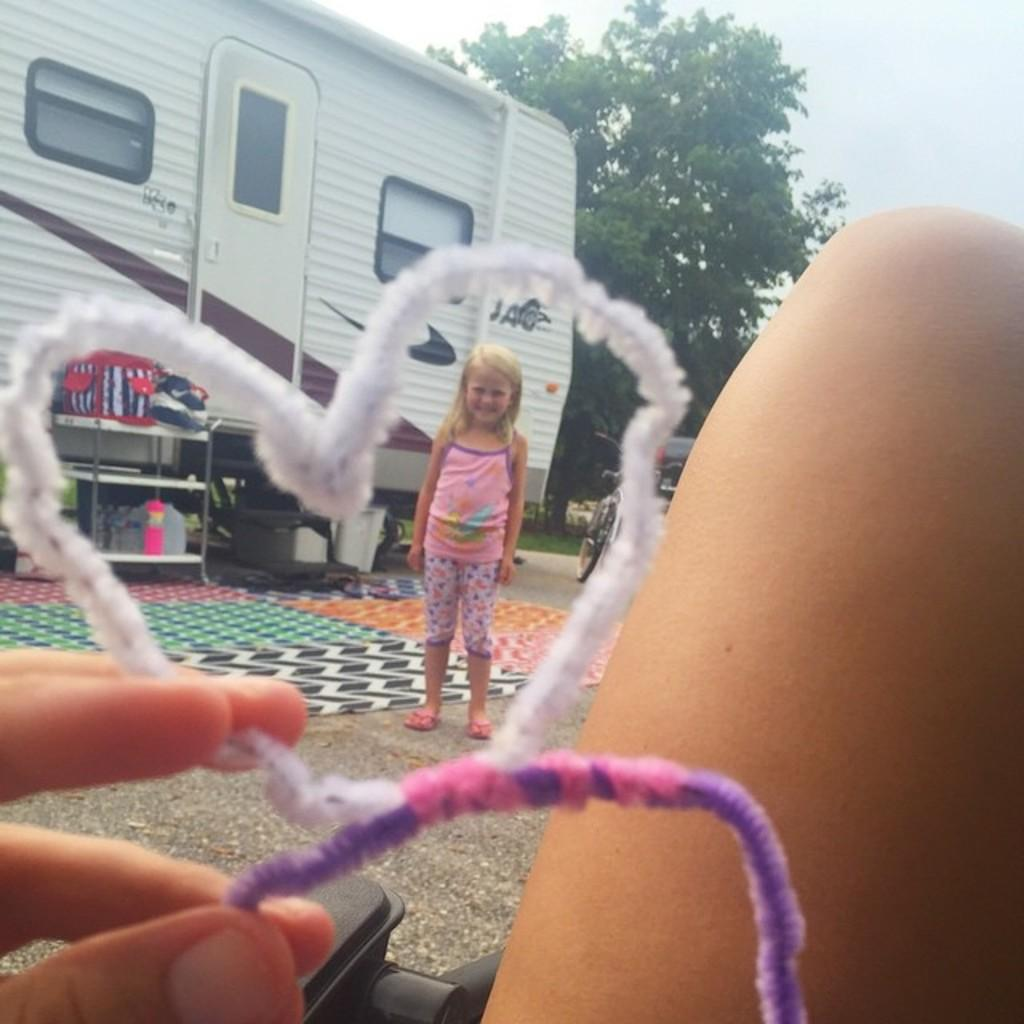How many people are in the image? There are two people in the image. What can be seen in the image besides the people? There is a tree, the sky, a bag, bottles, a bicycle, and a building visible in the image. What type of quilt is being used as a prop in the image? There is no quilt present in the image. What type of crime is being committed in the image? There is no crime being committed in the image. 